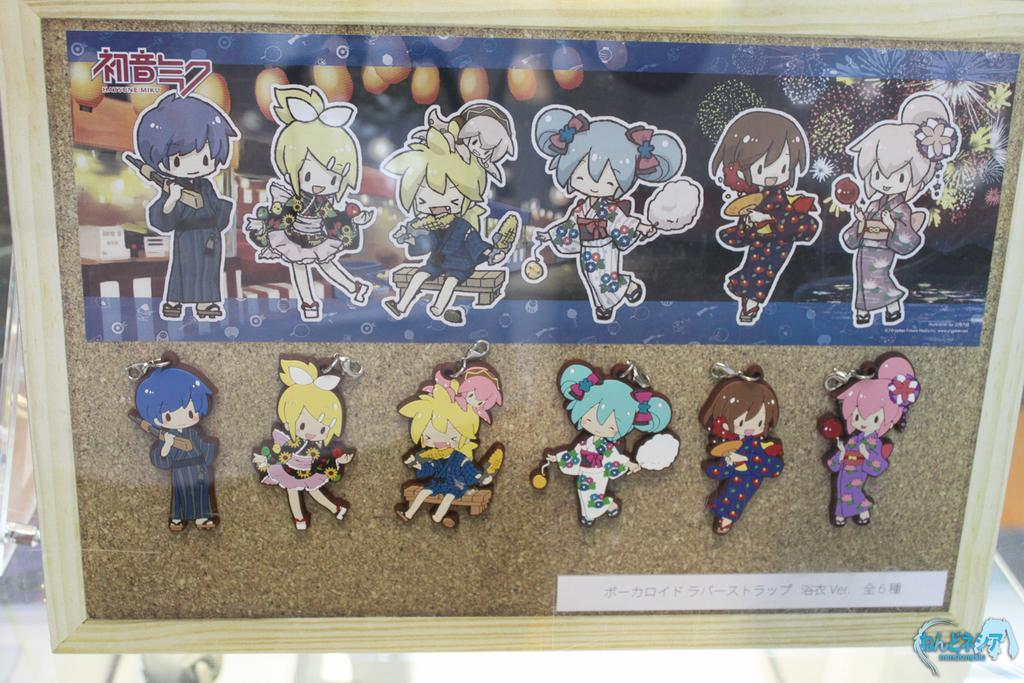What is the main object in the image? There is a board with a wooden frame in the image. What is on the board? Cartoon photos are pasted on the board. What type of fairies can be seen flying around the board in the image? There are no fairies present in the image; the board has cartoon photos pasted on it. What is the plot of the story depicted on the board in the image? The image does not depict a story or plot; it simply shows a board with cartoon photos pasted on it. 